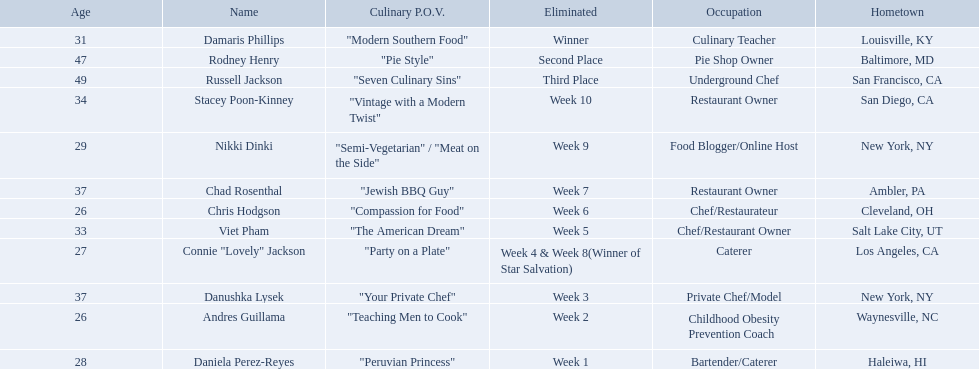Excluding the winner, and second and third place winners, who were the contestants eliminated? Stacey Poon-Kinney, Nikki Dinki, Chad Rosenthal, Chris Hodgson, Viet Pham, Connie "Lovely" Jackson, Danushka Lysek, Andres Guillama, Daniela Perez-Reyes. Of these contestants, who were the last five eliminated before the winner, second, and third place winners were announce? Stacey Poon-Kinney, Nikki Dinki, Chad Rosenthal, Chris Hodgson, Viet Pham. Of these five contestants, was nikki dinki or viet pham eliminated first? Viet Pham. Who are the  food network stars? Damaris Phillips, Rodney Henry, Russell Jackson, Stacey Poon-Kinney, Nikki Dinki, Chad Rosenthal, Chris Hodgson, Viet Pham, Connie "Lovely" Jackson, Danushka Lysek, Andres Guillama, Daniela Perez-Reyes. When did nikki dinki get eliminated? Week 9. When did viet pham get eliminated? Week 5. Which week came first? Week 5. Who was it that was eliminated week 5? Viet Pham. 